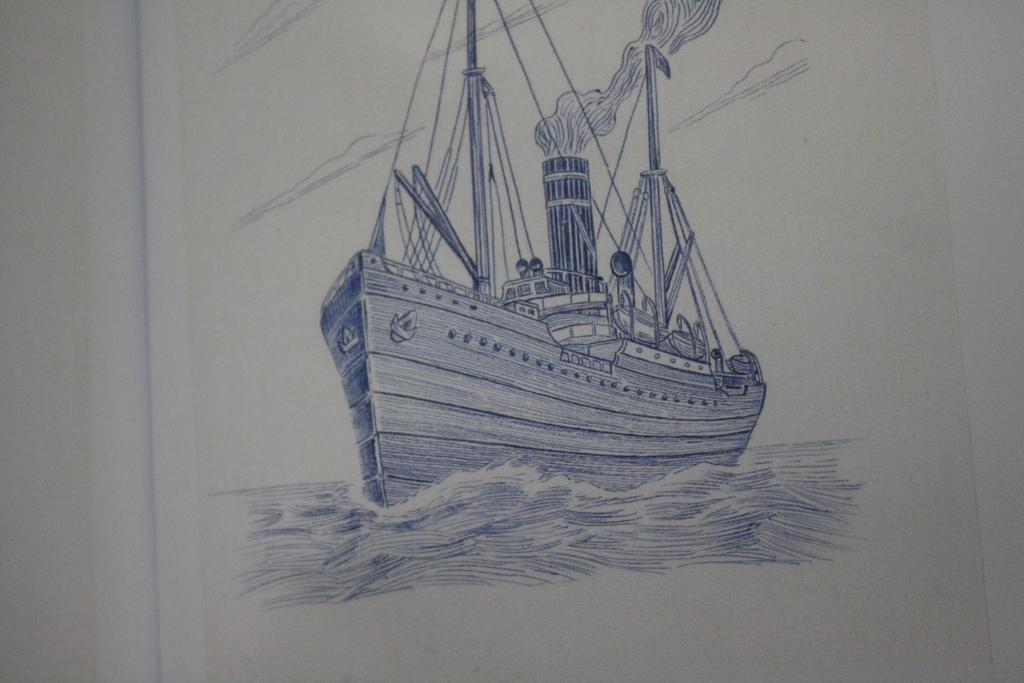What is the main subject of the drawing in the image? The main subject of the drawing in the image is a boat. Where is the boat located in the drawing? The boat is in the center of the drawing. What body of water is depicted in the drawing? There is a river at the bottom of the drawing. What type of nerve is visible in the drawing? There is no nerve present in the drawing; it features a boat and a river. What role does the fireman play in the drawing? There is no fireman present in the drawing; it only contains a boat and a river. 